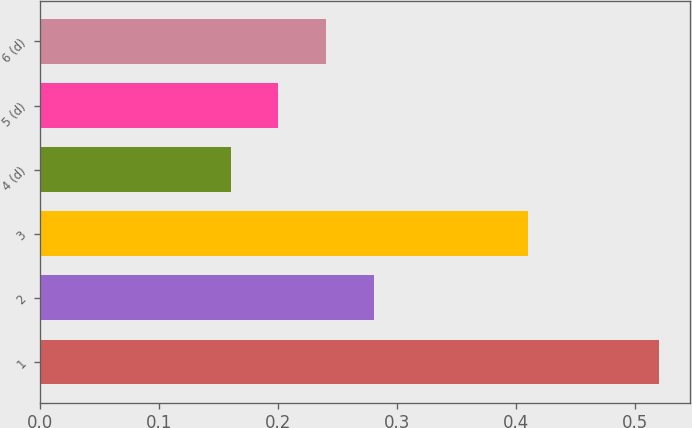Convert chart to OTSL. <chart><loc_0><loc_0><loc_500><loc_500><bar_chart><fcel>1<fcel>2<fcel>3<fcel>4 (d)<fcel>5 (d)<fcel>6 (d)<nl><fcel>0.52<fcel>0.28<fcel>0.41<fcel>0.16<fcel>0.2<fcel>0.24<nl></chart> 